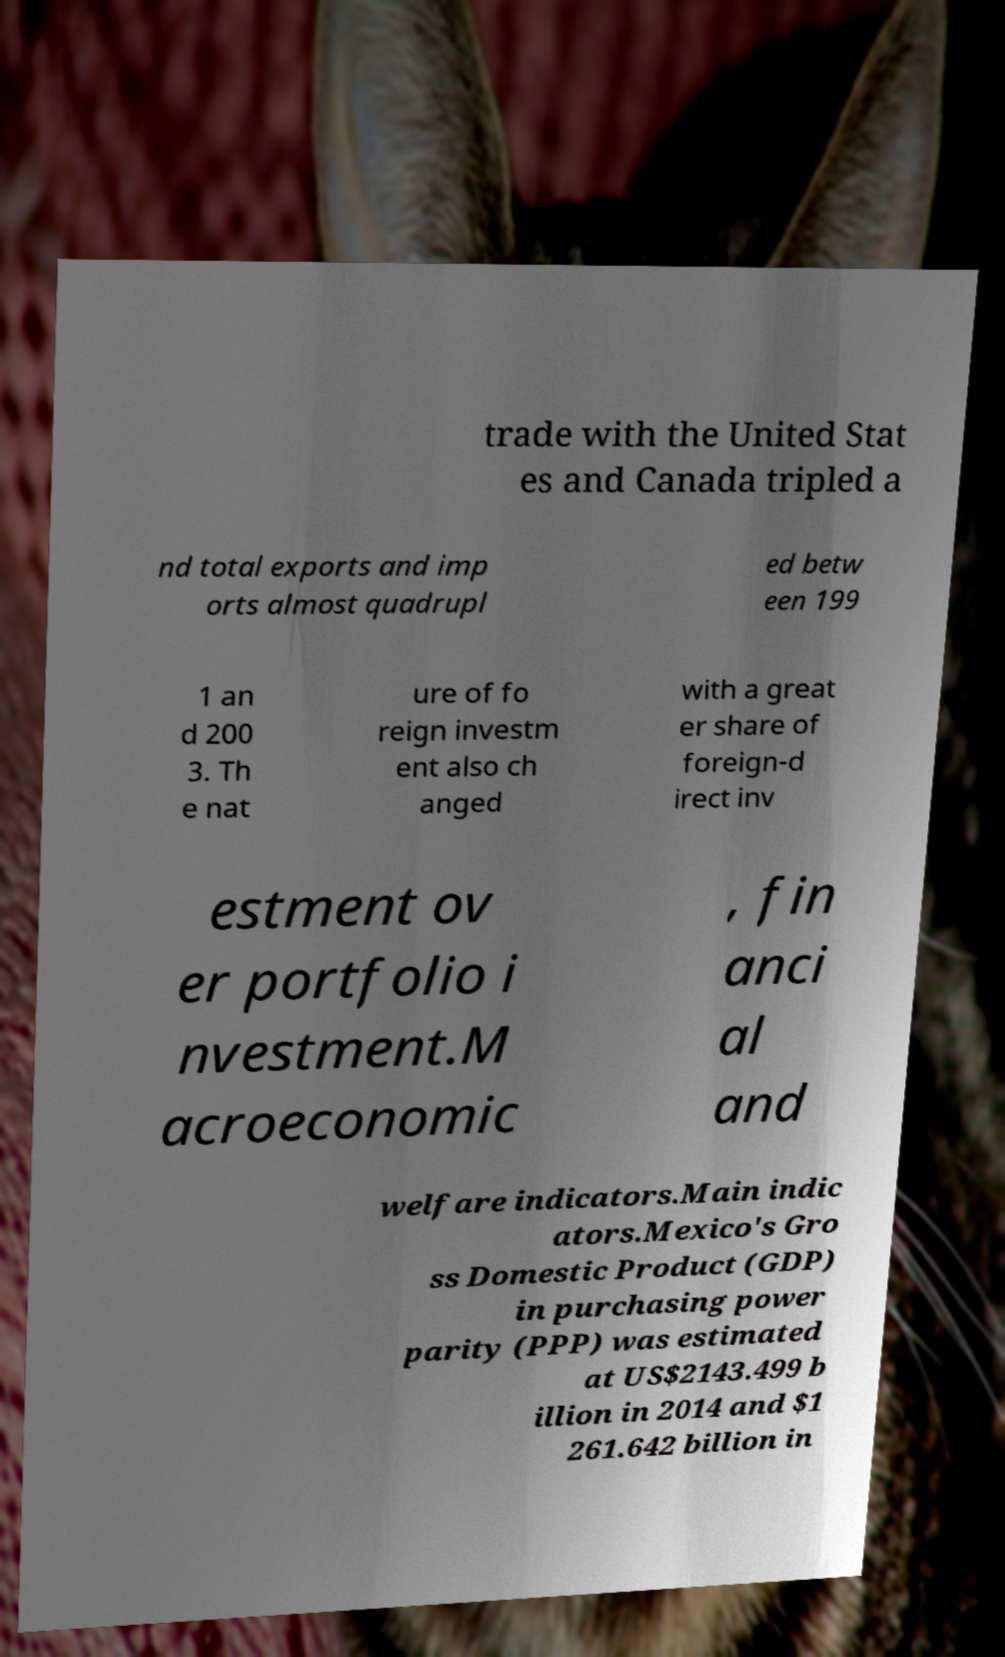Please identify and transcribe the text found in this image. trade with the United Stat es and Canada tripled a nd total exports and imp orts almost quadrupl ed betw een 199 1 an d 200 3. Th e nat ure of fo reign investm ent also ch anged with a great er share of foreign-d irect inv estment ov er portfolio i nvestment.M acroeconomic , fin anci al and welfare indicators.Main indic ators.Mexico's Gro ss Domestic Product (GDP) in purchasing power parity (PPP) was estimated at US$2143.499 b illion in 2014 and $1 261.642 billion in 